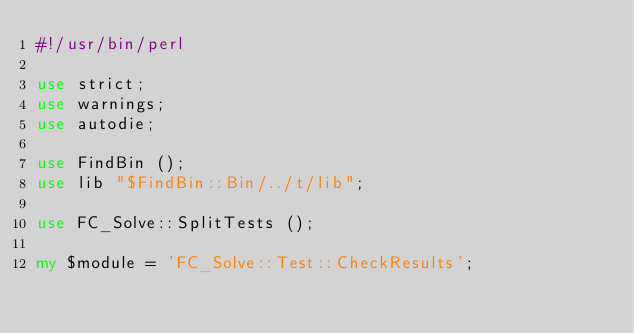Convert code to text. <code><loc_0><loc_0><loc_500><loc_500><_Perl_>#!/usr/bin/perl

use strict;
use warnings;
use autodie;

use FindBin ();
use lib "$FindBin::Bin/../t/lib";

use FC_Solve::SplitTests ();

my $module = 'FC_Solve::Test::CheckResults';</code> 